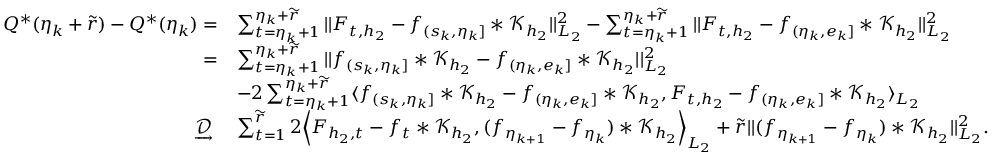<formula> <loc_0><loc_0><loc_500><loc_500>\begin{array} { r l } { Q ^ { * } ( \eta _ { k } + \widetilde { r } ) - Q ^ { * } ( \eta _ { k } ) = } & { \sum _ { t = \eta _ { k } + 1 } ^ { \eta _ { k } + \widetilde { r } } | | F _ { t , { h _ { 2 } } } - f _ { ( s _ { k } , \eta _ { k } ] } \ast \mathcal { K } _ { { h _ { 2 } } } | | _ { L _ { 2 } } ^ { 2 } - \sum _ { t = \eta _ { k } + 1 } ^ { \eta _ { k } + \widetilde { r } } | | F _ { t , { h _ { 2 } } } - f _ { ( \eta _ { k } , e _ { k } ] } \ast \mathcal { K } _ { h _ { 2 } } | | _ { L _ { 2 } } ^ { 2 } } \\ { = } & { \sum _ { t = \eta _ { k } + 1 } ^ { \eta _ { k } + \widetilde { r } } | | f _ { ( s _ { k } , \eta _ { k } ] } \ast \mathcal { K } _ { { h _ { 2 } } } - f _ { ( \eta _ { k } , e _ { k } ] } \ast \mathcal { K } _ { h _ { 2 } } | | _ { L _ { 2 } } ^ { 2 } } \\ & { - 2 \sum _ { t = \eta _ { k } + 1 } ^ { \eta _ { k } + \widetilde { r } } \langle f _ { ( s _ { k } , \eta _ { k } ] } \ast \mathcal { K } _ { { h _ { 2 } } } - f _ { ( \eta _ { k } , e _ { k } ] } \ast \mathcal { K } _ { h _ { 2 } } , F _ { t , { h _ { 2 } } } - f _ { ( \eta _ { k } , e _ { k } ] } \ast \mathcal { K } _ { h _ { 2 } } \rangle _ { L _ { 2 } } } \\ { \ \underrightarrow { \mathcal { D } } \ } & { \sum _ { t = 1 } ^ { \widetilde { r } } 2 \left \langle F _ { { h _ { 2 } } , t } - f _ { t } * \mathcal { K } _ { h _ { 2 } } , ( f _ { \eta _ { k + 1 } } - f _ { \eta _ { k } } ) * \mathcal { K } _ { h _ { 2 } } \right \rangle _ { L _ { 2 } } + \widetilde { r } | | ( f _ { \eta _ { k + 1 } } - f _ { \eta _ { k } } ) * \mathcal { K } _ { h _ { 2 } } | | _ { L _ { 2 } } ^ { 2 } . } \end{array}</formula> 